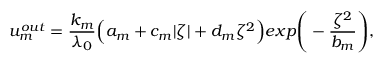Convert formula to latex. <formula><loc_0><loc_0><loc_500><loc_500>u _ { m } ^ { o u t } = \frac { k _ { m } } { \lambda _ { 0 } } \left ( a _ { m } + c _ { m } | \zeta | + d _ { m } \zeta ^ { 2 } \right ) e x p \left ( - \frac { \zeta ^ { 2 } } { b _ { m } } \right ) ,</formula> 